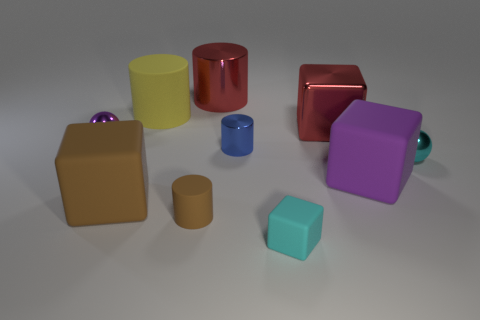Subtract all brown cubes. How many cubes are left? 3 Subtract all rubber blocks. How many blocks are left? 1 Subtract 2 cylinders. How many cylinders are left? 2 Subtract all cylinders. How many objects are left? 6 Subtract all blue cylinders. Subtract all green balls. How many cylinders are left? 3 Subtract all blue metal spheres. Subtract all blue cylinders. How many objects are left? 9 Add 6 small cyan spheres. How many small cyan spheres are left? 7 Add 6 purple cubes. How many purple cubes exist? 7 Subtract 0 yellow balls. How many objects are left? 10 